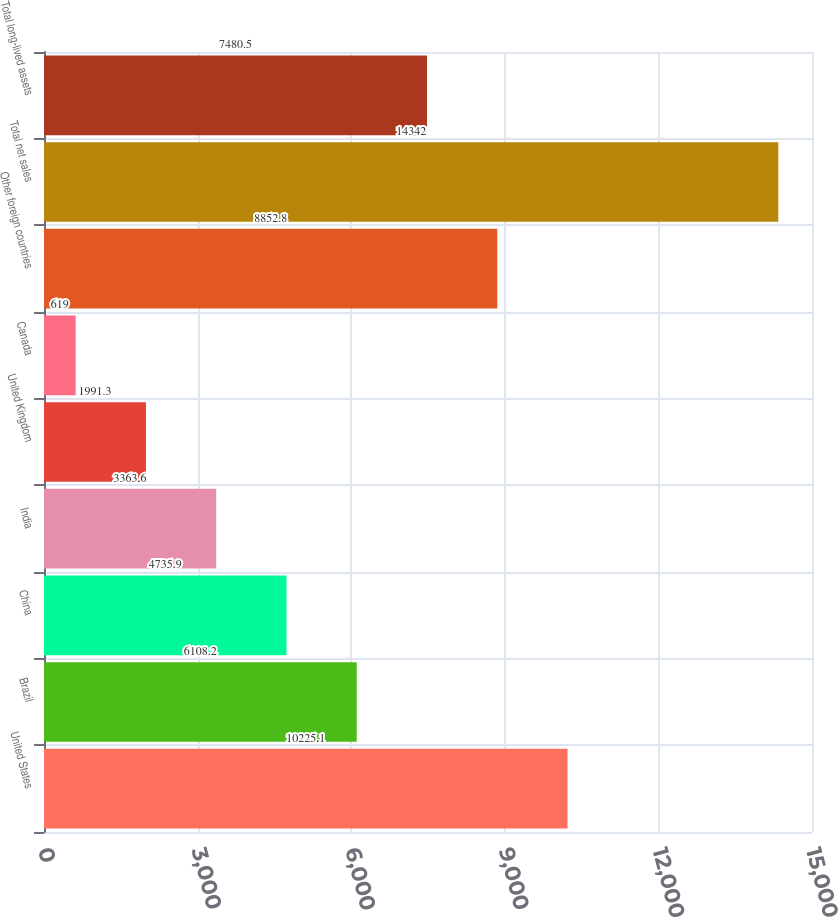Convert chart. <chart><loc_0><loc_0><loc_500><loc_500><bar_chart><fcel>United States<fcel>Brazil<fcel>China<fcel>India<fcel>United Kingdom<fcel>Canada<fcel>Other foreign countries<fcel>Total net sales<fcel>Total long-lived assets<nl><fcel>10225.1<fcel>6108.2<fcel>4735.9<fcel>3363.6<fcel>1991.3<fcel>619<fcel>8852.8<fcel>14342<fcel>7480.5<nl></chart> 